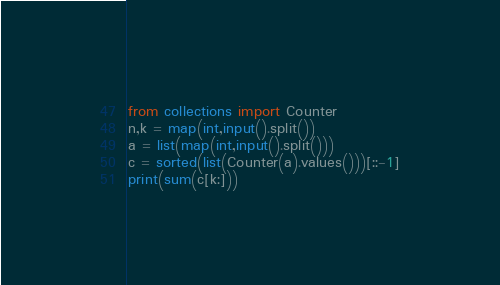Convert code to text. <code><loc_0><loc_0><loc_500><loc_500><_Python_>from collections import Counter
n,k = map(int,input().split())
a = list(map(int,input().split()))
c = sorted(list(Counter(a).values()))[::-1]
print(sum(c[k:]))</code> 